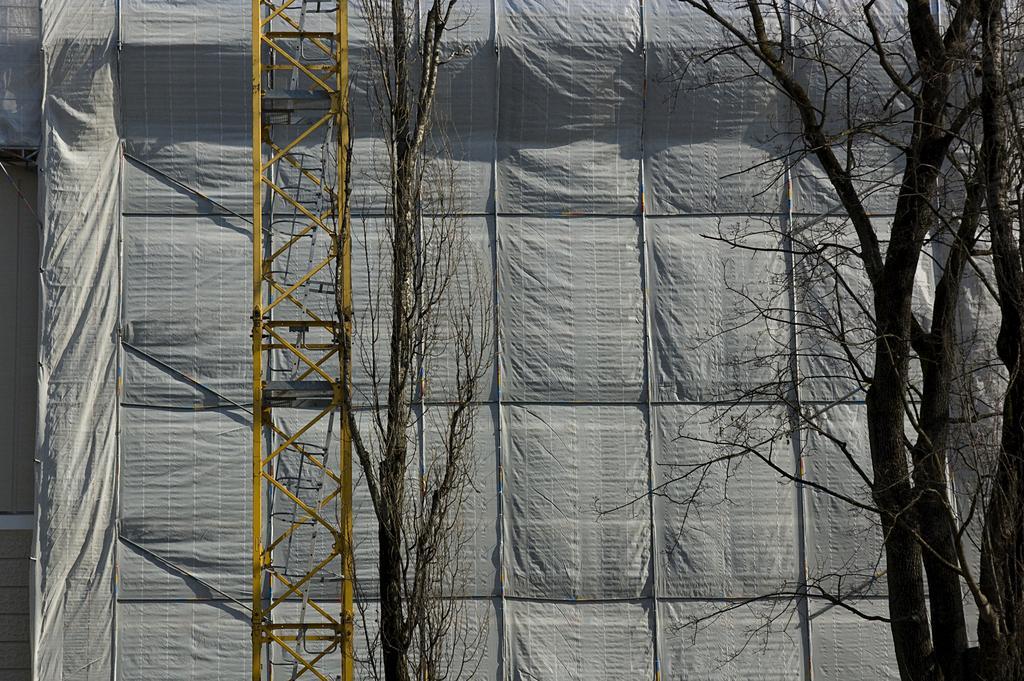In one or two sentences, can you explain what this image depicts? In the foreground of the image there are trees. In the background of the image there is a cover. There is a tower. 